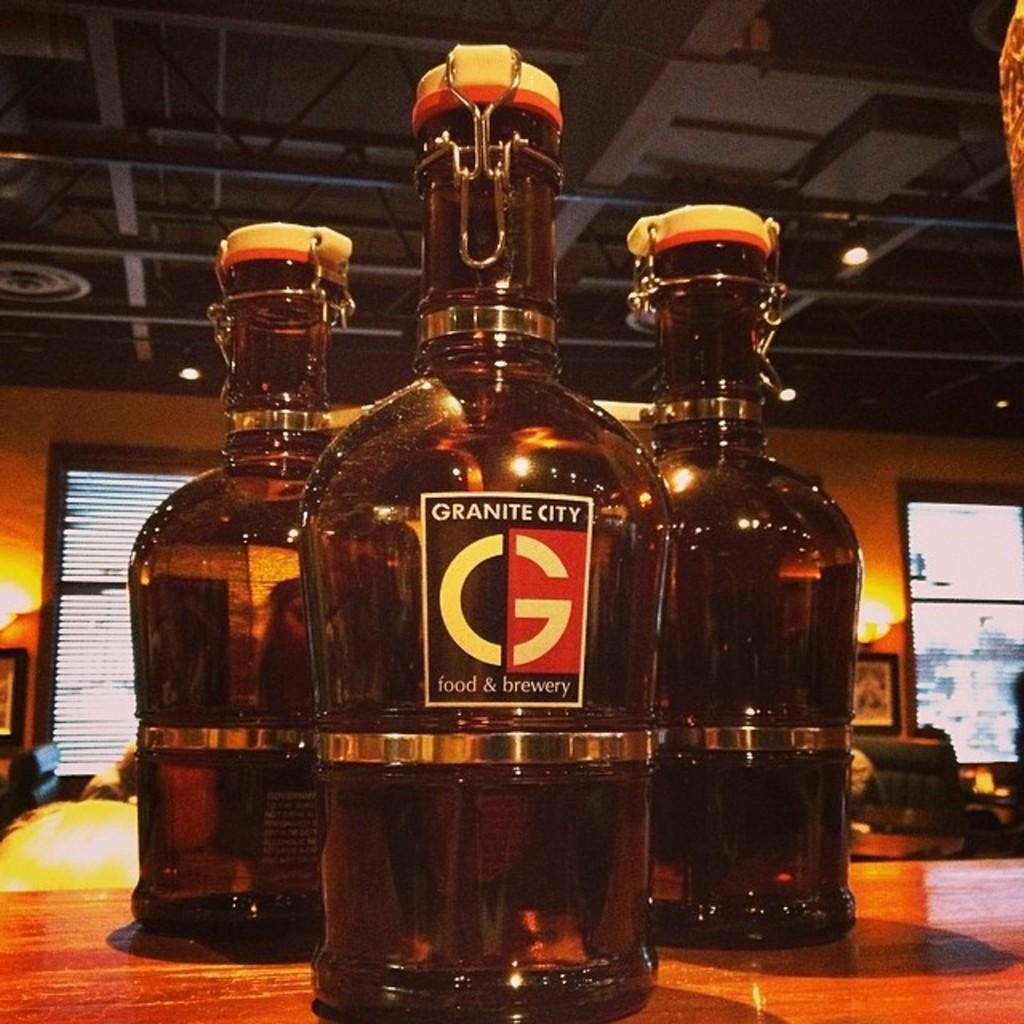<image>
Render a clear and concise summary of the photo. Granite City food & brewery has some bottles on display. 